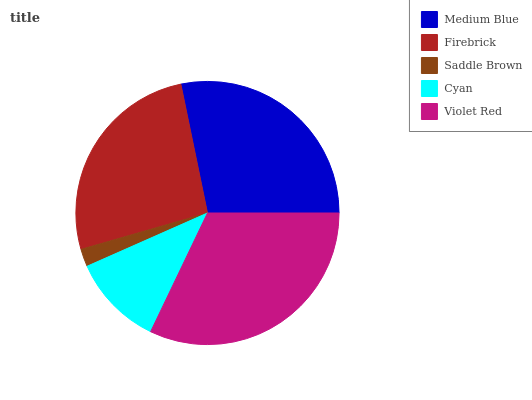Is Saddle Brown the minimum?
Answer yes or no. Yes. Is Violet Red the maximum?
Answer yes or no. Yes. Is Firebrick the minimum?
Answer yes or no. No. Is Firebrick the maximum?
Answer yes or no. No. Is Medium Blue greater than Firebrick?
Answer yes or no. Yes. Is Firebrick less than Medium Blue?
Answer yes or no. Yes. Is Firebrick greater than Medium Blue?
Answer yes or no. No. Is Medium Blue less than Firebrick?
Answer yes or no. No. Is Firebrick the high median?
Answer yes or no. Yes. Is Firebrick the low median?
Answer yes or no. Yes. Is Medium Blue the high median?
Answer yes or no. No. Is Medium Blue the low median?
Answer yes or no. No. 